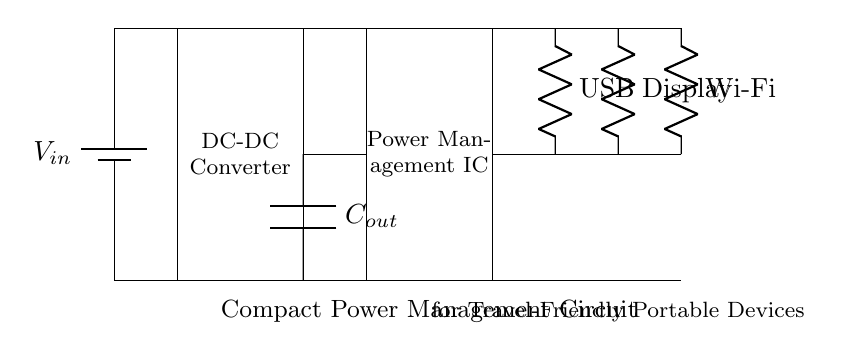What is the power source for this circuit? The power source is a battery, indicated by the symbol in the diagram labeled as $V_{in}$. It is connected at the top of the circuit and supplies power to the other components.
Answer: Battery What does the rectangular block between the battery and the power management IC represent? The rectangular block is labeled as a DC-DC Converter, which is responsible for converting voltage levels to the appropriate value required by the circuit.
Answer: DC-DC Converter How many loads are present in this circuit? There are three loads in the circuit: USB, Display, and Wi-Fi, which are represented by resistors connected to the power management IC.
Answer: Three What is the purpose of the output capacitor in this circuit? The output capacitor ($C_{out}$) smooths the voltage output from the DC-DC converter before it reaches the power management IC, ensuring stable power delivery to the loads.
Answer: Smoothing voltage Which component is responsible for managing the power distribution to the loads? The Power Management IC is responsible for managing the power distribution. It regulates the power from the DC-DC converter to the various loads connected to it.
Answer: Power Management IC Why is a DC-DC converter necessary in this circuit? A DC-DC converter is necessary to change the input voltage from the battery to a lower or higher voltage that is suitable for the loads, ensuring optimal functionality without damaging any components.
Answer: To adjust voltage levels 